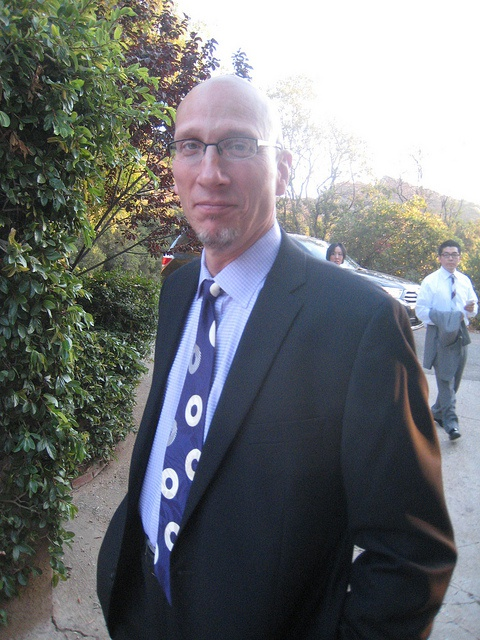Describe the objects in this image and their specific colors. I can see people in gray, black, and darkblue tones, tie in gray, blue, lavender, and navy tones, people in gray, white, and lightblue tones, car in gray, white, and darkgray tones, and people in gray, darkgray, and pink tones in this image. 